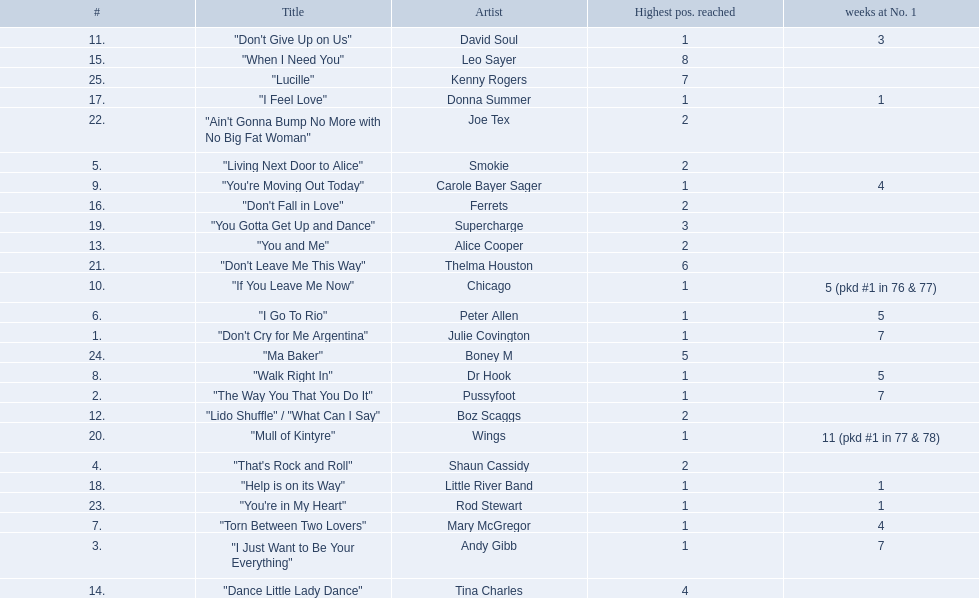Which artists were included in the top 25 singles for 1977 in australia? Julie Covington, Pussyfoot, Andy Gibb, Shaun Cassidy, Smokie, Peter Allen, Mary McGregor, Dr Hook, Carole Bayer Sager, Chicago, David Soul, Boz Scaggs, Alice Cooper, Tina Charles, Leo Sayer, Ferrets, Donna Summer, Little River Band, Supercharge, Wings, Thelma Houston, Joe Tex, Rod Stewart, Boney M, Kenny Rogers. And for how many weeks did they chart at number 1? 7, 7, 7, , , 5, 4, 5, 4, 5 (pkd #1 in 76 & 77), 3, , , , , , 1, 1, , 11 (pkd #1 in 77 & 78), , , 1, , . Which artist was in the number 1 spot for most time? Wings. 